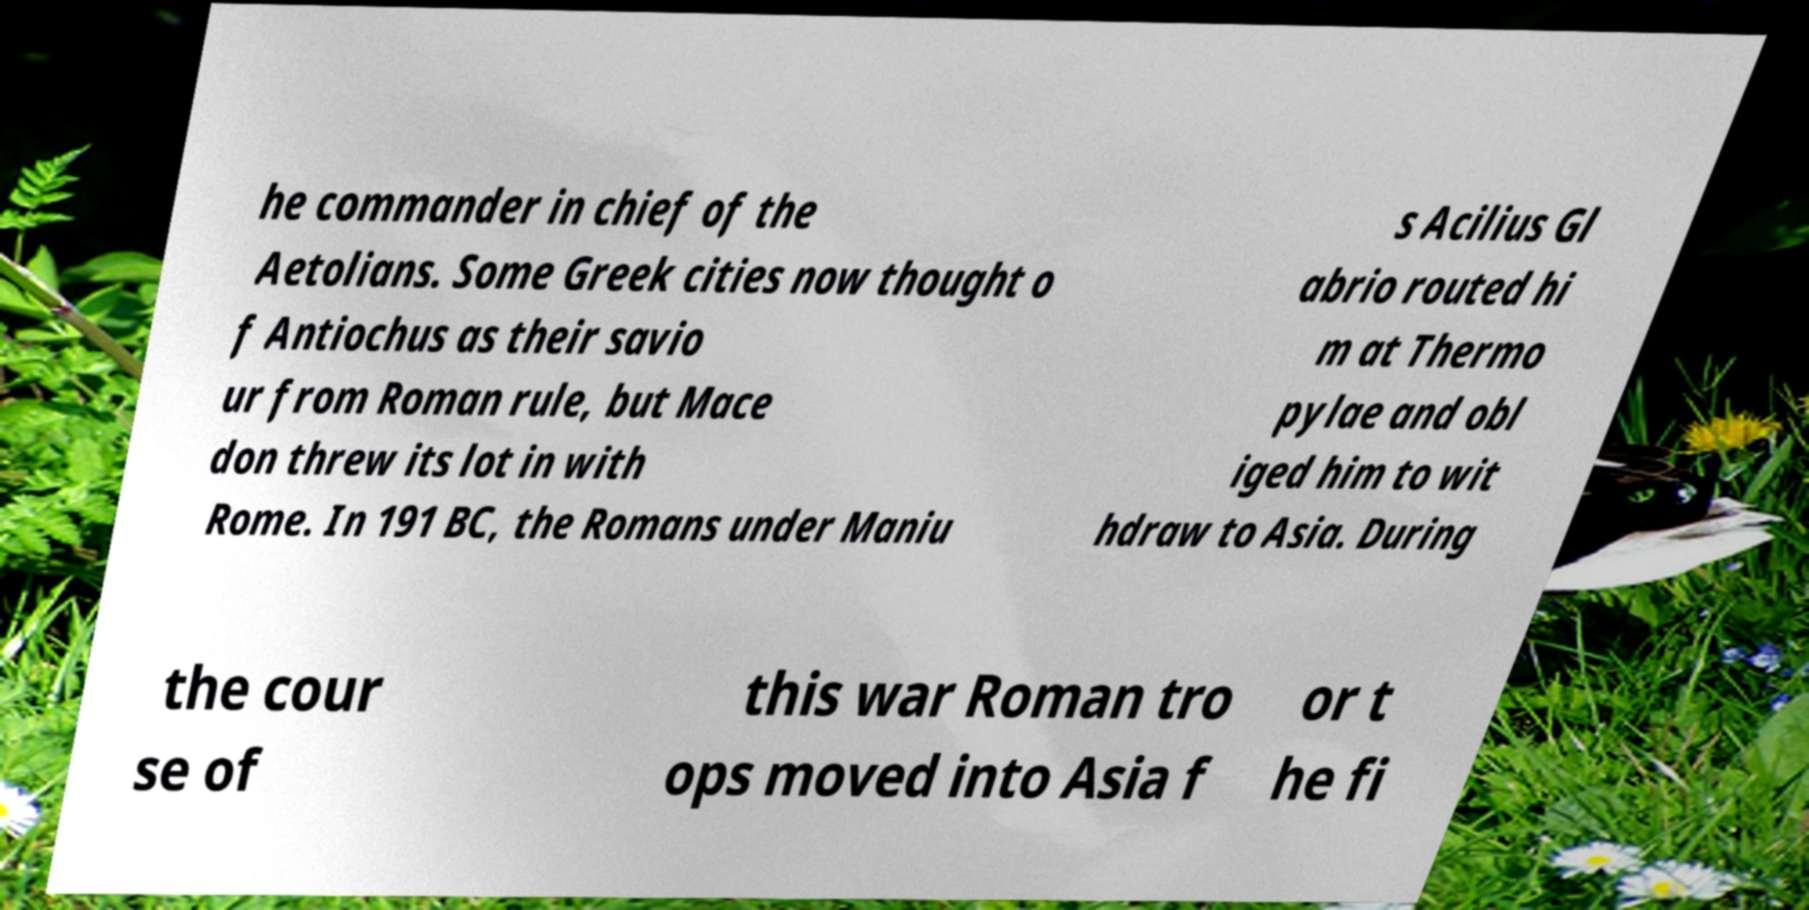For documentation purposes, I need the text within this image transcribed. Could you provide that? he commander in chief of the Aetolians. Some Greek cities now thought o f Antiochus as their savio ur from Roman rule, but Mace don threw its lot in with Rome. In 191 BC, the Romans under Maniu s Acilius Gl abrio routed hi m at Thermo pylae and obl iged him to wit hdraw to Asia. During the cour se of this war Roman tro ops moved into Asia f or t he fi 